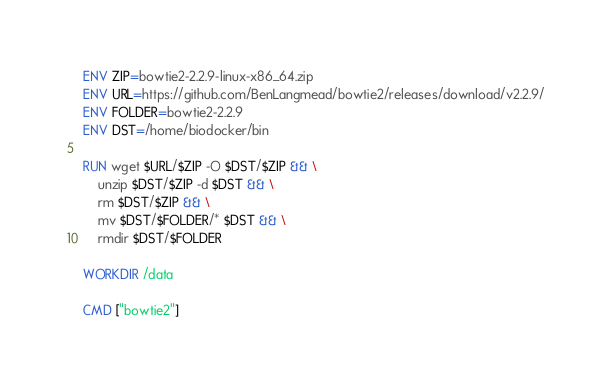<code> <loc_0><loc_0><loc_500><loc_500><_Dockerfile_>ENV ZIP=bowtie2-2.2.9-linux-x86_64.zip
ENV URL=https://github.com/BenLangmead/bowtie2/releases/download/v2.2.9/
ENV FOLDER=bowtie2-2.2.9
ENV DST=/home/biodocker/bin

RUN wget $URL/$ZIP -O $DST/$ZIP && \
    unzip $DST/$ZIP -d $DST && \
    rm $DST/$ZIP && \
    mv $DST/$FOLDER/* $DST && \
    rmdir $DST/$FOLDER

WORKDIR /data

CMD ["bowtie2"]
</code> 